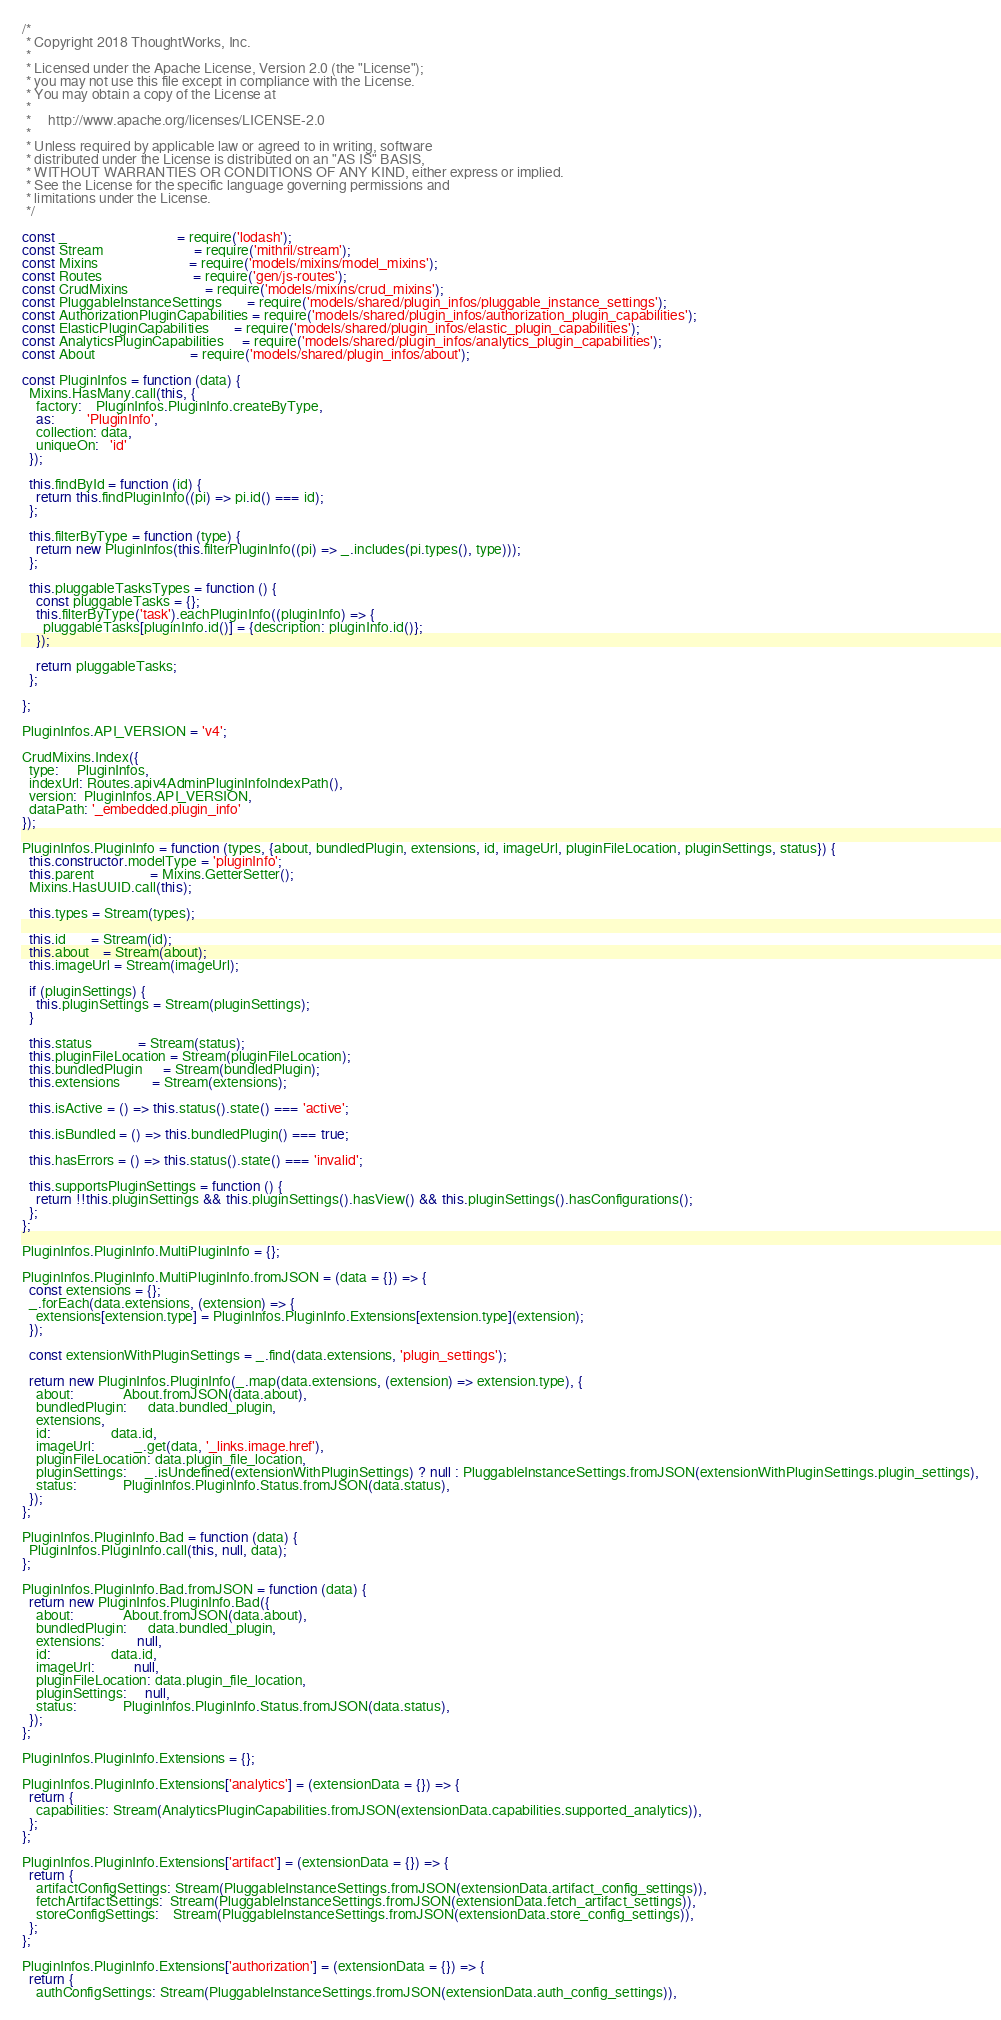Convert code to text. <code><loc_0><loc_0><loc_500><loc_500><_JavaScript_>/*
 * Copyright 2018 ThoughtWorks, Inc.
 *
 * Licensed under the Apache License, Version 2.0 (the "License");
 * you may not use this file except in compliance with the License.
 * You may obtain a copy of the License at
 *
 *     http://www.apache.org/licenses/LICENSE-2.0
 *
 * Unless required by applicable law or agreed to in writing, software
 * distributed under the License is distributed on an "AS IS" BASIS,
 * WITHOUT WARRANTIES OR CONDITIONS OF ANY KIND, either express or implied.
 * See the License for the specific language governing permissions and
 * limitations under the License.
 */

const _                               = require('lodash');
const Stream                          = require('mithril/stream');
const Mixins                          = require('models/mixins/model_mixins');
const Routes                          = require('gen/js-routes');
const CrudMixins                      = require('models/mixins/crud_mixins');
const PluggableInstanceSettings       = require('models/shared/plugin_infos/pluggable_instance_settings');
const AuthorizationPluginCapabilities = require('models/shared/plugin_infos/authorization_plugin_capabilities');
const ElasticPluginCapabilities       = require('models/shared/plugin_infos/elastic_plugin_capabilities');
const AnalyticsPluginCapabilities     = require('models/shared/plugin_infos/analytics_plugin_capabilities');
const About                           = require('models/shared/plugin_infos/about');

const PluginInfos = function (data) {
  Mixins.HasMany.call(this, {
    factory:    PluginInfos.PluginInfo.createByType,
    as:         'PluginInfo',
    collection: data,
    uniqueOn:   'id'
  });

  this.findById = function (id) {
    return this.findPluginInfo((pi) => pi.id() === id);
  };

  this.filterByType = function (type) {
    return new PluginInfos(this.filterPluginInfo((pi) => _.includes(pi.types(), type)));
  };

  this.pluggableTasksTypes = function () {
    const pluggableTasks = {};
    this.filterByType('task').eachPluginInfo((pluginInfo) => {
      pluggableTasks[pluginInfo.id()] = {description: pluginInfo.id()};
    });

    return pluggableTasks;
  };

};

PluginInfos.API_VERSION = 'v4';

CrudMixins.Index({
  type:     PluginInfos,
  indexUrl: Routes.apiv4AdminPluginInfoIndexPath(),
  version:  PluginInfos.API_VERSION,
  dataPath: '_embedded.plugin_info'
});

PluginInfos.PluginInfo = function (types, {about, bundledPlugin, extensions, id, imageUrl, pluginFileLocation, pluginSettings, status}) {
  this.constructor.modelType = 'pluginInfo';
  this.parent                = Mixins.GetterSetter();
  Mixins.HasUUID.call(this);

  this.types = Stream(types);

  this.id       = Stream(id);
  this.about    = Stream(about);
  this.imageUrl = Stream(imageUrl);

  if (pluginSettings) {
    this.pluginSettings = Stream(pluginSettings);
  }

  this.status             = Stream(status);
  this.pluginFileLocation = Stream(pluginFileLocation);
  this.bundledPlugin      = Stream(bundledPlugin);
  this.extensions         = Stream(extensions);

  this.isActive = () => this.status().state() === 'active';

  this.isBundled = () => this.bundledPlugin() === true;

  this.hasErrors = () => this.status().state() === 'invalid';

  this.supportsPluginSettings = function () {
    return !!this.pluginSettings && this.pluginSettings().hasView() && this.pluginSettings().hasConfigurations();
  };
};

PluginInfos.PluginInfo.MultiPluginInfo = {};

PluginInfos.PluginInfo.MultiPluginInfo.fromJSON = (data = {}) => {
  const extensions = {};
  _.forEach(data.extensions, (extension) => {
    extensions[extension.type] = PluginInfos.PluginInfo.Extensions[extension.type](extension);
  });

  const extensionWithPluginSettings = _.find(data.extensions, 'plugin_settings');

  return new PluginInfos.PluginInfo(_.map(data.extensions, (extension) => extension.type), {
    about:              About.fromJSON(data.about),
    bundledPlugin:      data.bundled_plugin,
    extensions,
    id:                 data.id,
    imageUrl:           _.get(data, '_links.image.href'),
    pluginFileLocation: data.plugin_file_location,
    pluginSettings:     _.isUndefined(extensionWithPluginSettings) ? null : PluggableInstanceSettings.fromJSON(extensionWithPluginSettings.plugin_settings),
    status:             PluginInfos.PluginInfo.Status.fromJSON(data.status),
  });
};

PluginInfos.PluginInfo.Bad = function (data) {
  PluginInfos.PluginInfo.call(this, null, data);
};

PluginInfos.PluginInfo.Bad.fromJSON = function (data) {
  return new PluginInfos.PluginInfo.Bad({
    about:              About.fromJSON(data.about),
    bundledPlugin:      data.bundled_plugin,
    extensions:         null,
    id:                 data.id,
    imageUrl:           null,
    pluginFileLocation: data.plugin_file_location,
    pluginSettings:     null,
    status:             PluginInfos.PluginInfo.Status.fromJSON(data.status),
  });
};

PluginInfos.PluginInfo.Extensions = {};

PluginInfos.PluginInfo.Extensions['analytics'] = (extensionData = {}) => {
  return {
    capabilities: Stream(AnalyticsPluginCapabilities.fromJSON(extensionData.capabilities.supported_analytics)),
  };
};

PluginInfos.PluginInfo.Extensions['artifact'] = (extensionData = {}) => {
  return {
    artifactConfigSettings: Stream(PluggableInstanceSettings.fromJSON(extensionData.artifact_config_settings)),
    fetchArtifactSettings:  Stream(PluggableInstanceSettings.fromJSON(extensionData.fetch_artifact_settings)),
    storeConfigSettings:    Stream(PluggableInstanceSettings.fromJSON(extensionData.store_config_settings)),
  };
};

PluginInfos.PluginInfo.Extensions['authorization'] = (extensionData = {}) => {
  return {
    authConfigSettings: Stream(PluggableInstanceSettings.fromJSON(extensionData.auth_config_settings)),</code> 